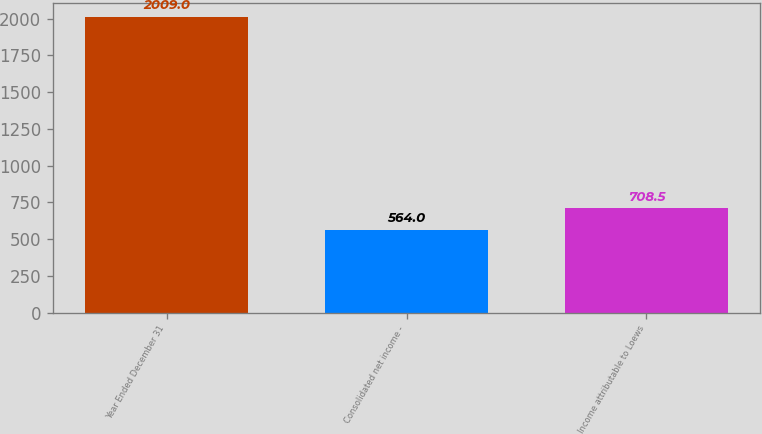Convert chart to OTSL. <chart><loc_0><loc_0><loc_500><loc_500><bar_chart><fcel>Year Ended December 31<fcel>Consolidated net income -<fcel>Income attributable to Loews<nl><fcel>2009<fcel>564<fcel>708.5<nl></chart> 